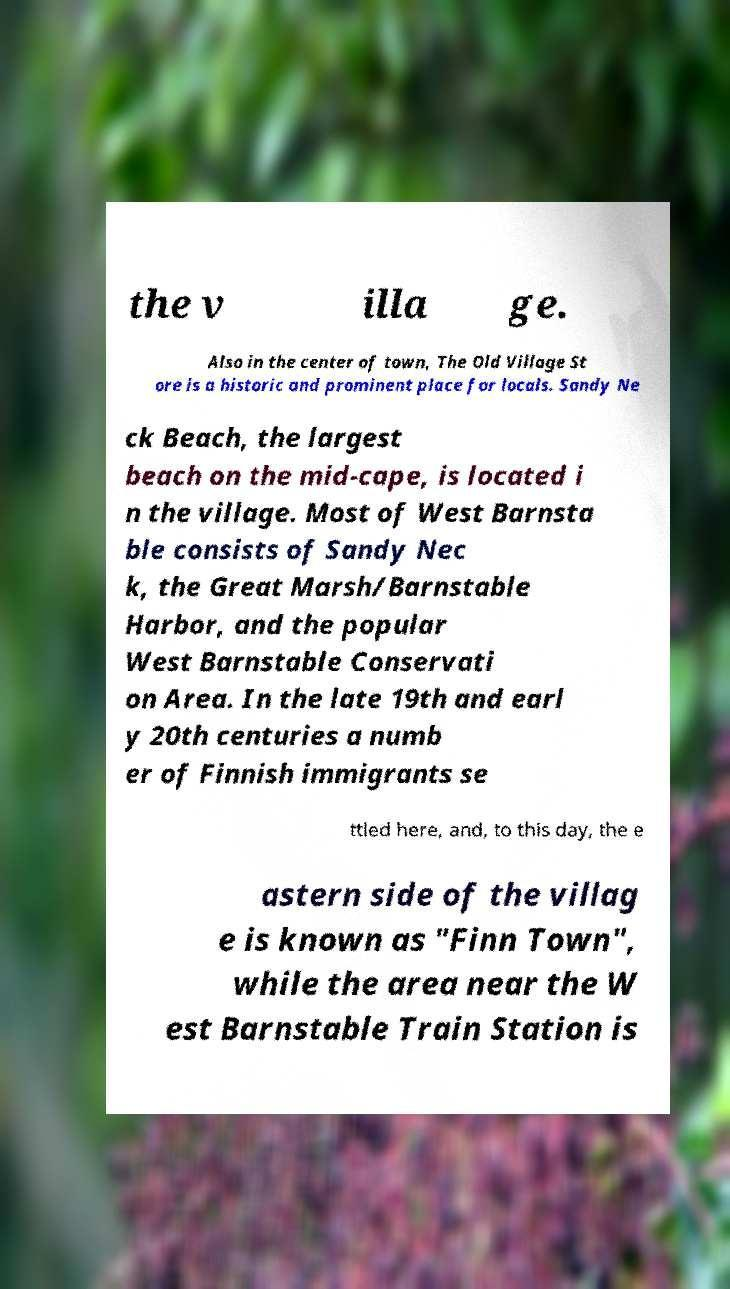Could you assist in decoding the text presented in this image and type it out clearly? the v illa ge. Also in the center of town, The Old Village St ore is a historic and prominent place for locals. Sandy Ne ck Beach, the largest beach on the mid-cape, is located i n the village. Most of West Barnsta ble consists of Sandy Nec k, the Great Marsh/Barnstable Harbor, and the popular West Barnstable Conservati on Area. In the late 19th and earl y 20th centuries a numb er of Finnish immigrants se ttled here, and, to this day, the e astern side of the villag e is known as "Finn Town", while the area near the W est Barnstable Train Station is 